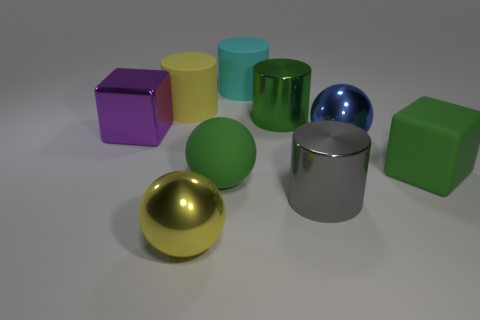Which objects in the image are the closest to the camera? The objects closest to the camera are the golden sphere and the silver cylinder. They appear to be placed front and center within the composition of the image. 